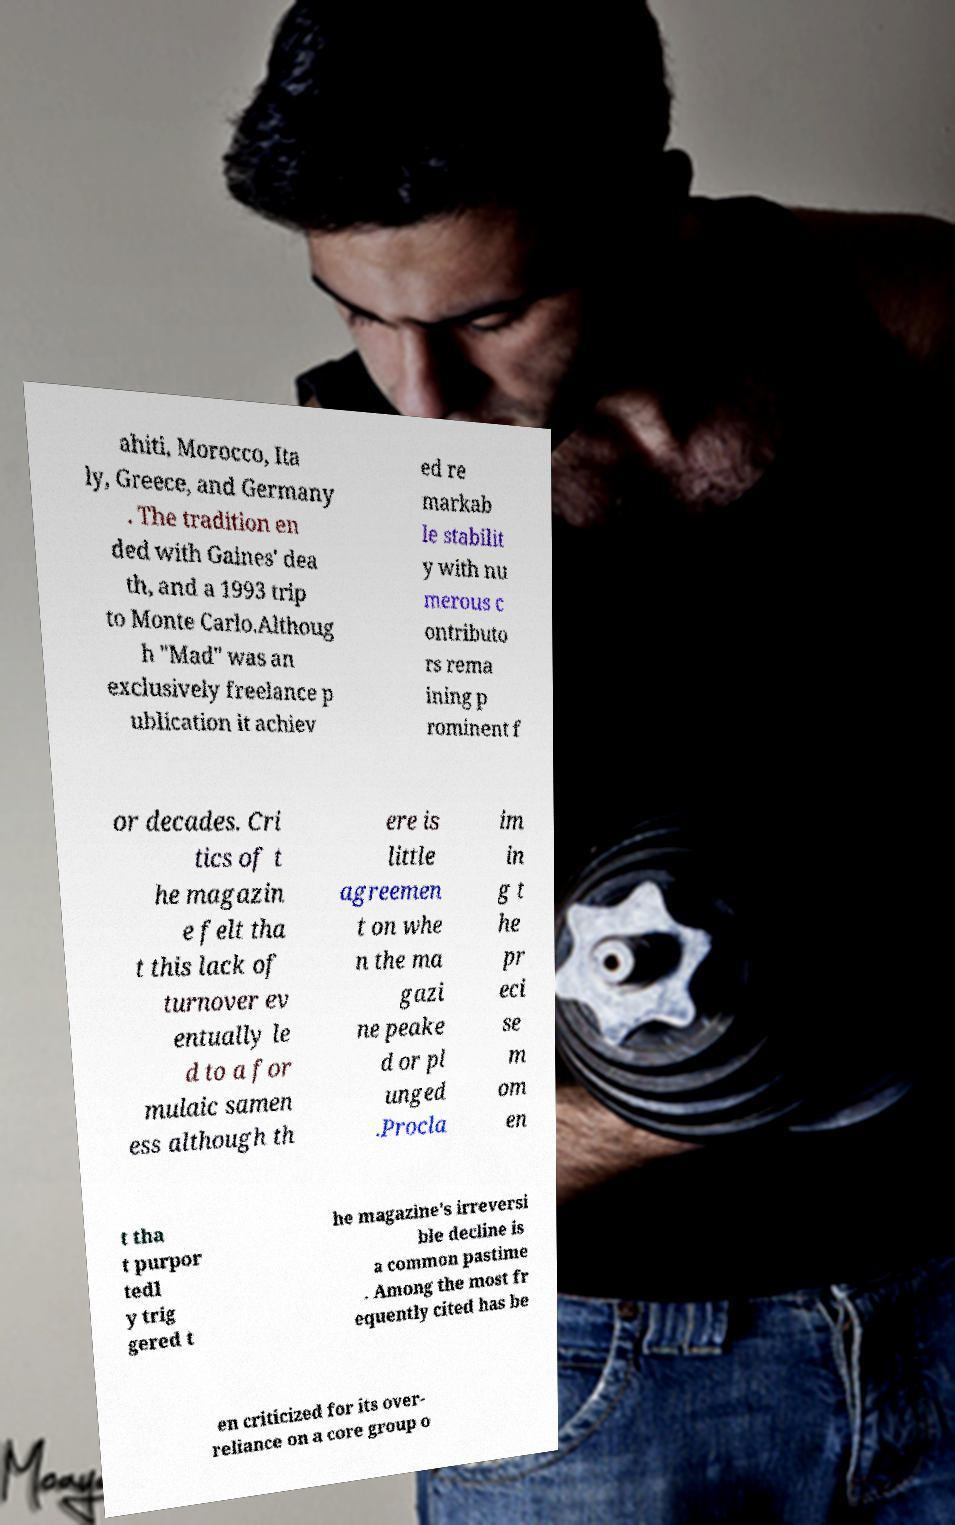What messages or text are displayed in this image? I need them in a readable, typed format. ahiti, Morocco, Ita ly, Greece, and Germany . The tradition en ded with Gaines' dea th, and a 1993 trip to Monte Carlo.Althoug h "Mad" was an exclusively freelance p ublication it achiev ed re markab le stabilit y with nu merous c ontributo rs rema ining p rominent f or decades. Cri tics of t he magazin e felt tha t this lack of turnover ev entually le d to a for mulaic samen ess although th ere is little agreemen t on whe n the ma gazi ne peake d or pl unged .Procla im in g t he pr eci se m om en t tha t purpor tedl y trig gered t he magazine's irreversi ble decline is a common pastime . Among the most fr equently cited has be en criticized for its over- reliance on a core group o 